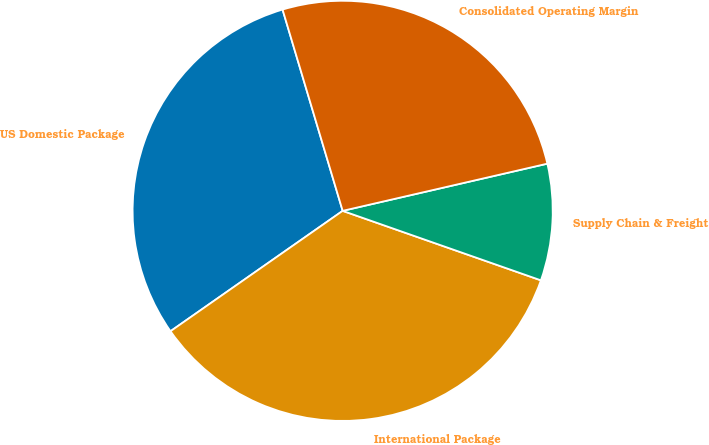Convert chart to OTSL. <chart><loc_0><loc_0><loc_500><loc_500><pie_chart><fcel>US Domestic Package<fcel>International Package<fcel>Supply Chain & Freight<fcel>Consolidated Operating Margin<nl><fcel>30.09%<fcel>34.92%<fcel>8.97%<fcel>26.01%<nl></chart> 